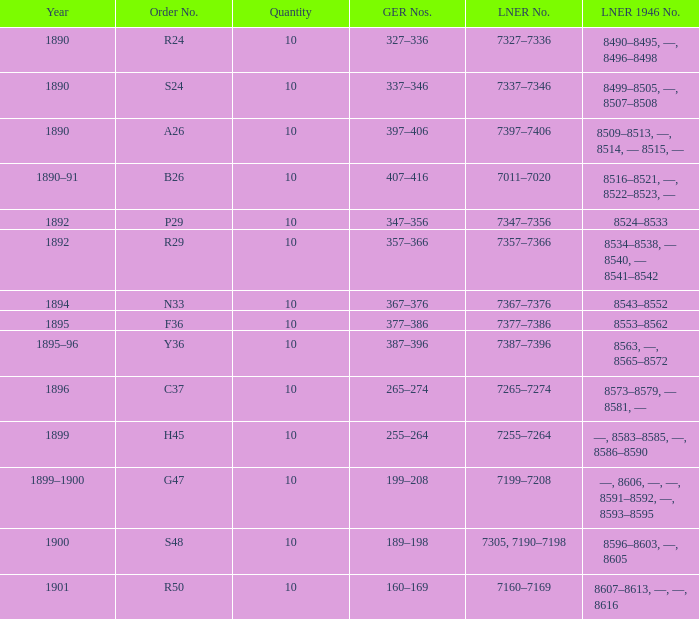Which lner 1946 digit is from 1892 and holds an lner number of 7347-7356? 8524–8533. 